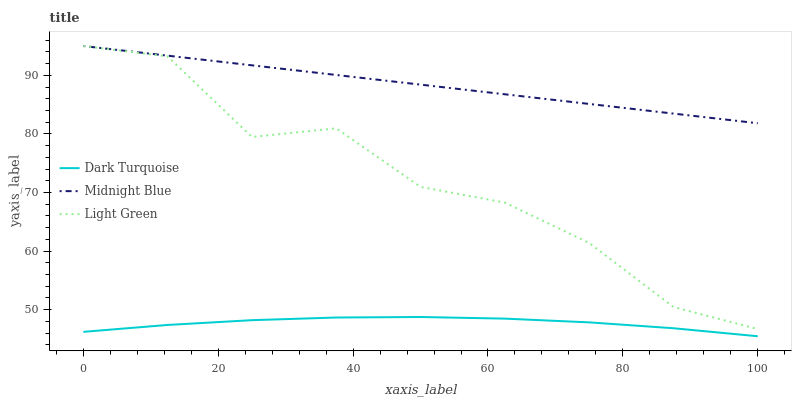Does Light Green have the minimum area under the curve?
Answer yes or no. No. Does Light Green have the maximum area under the curve?
Answer yes or no. No. Is Light Green the smoothest?
Answer yes or no. No. Is Midnight Blue the roughest?
Answer yes or no. No. Does Light Green have the lowest value?
Answer yes or no. No. Is Dark Turquoise less than Light Green?
Answer yes or no. Yes. Is Midnight Blue greater than Dark Turquoise?
Answer yes or no. Yes. Does Dark Turquoise intersect Light Green?
Answer yes or no. No. 